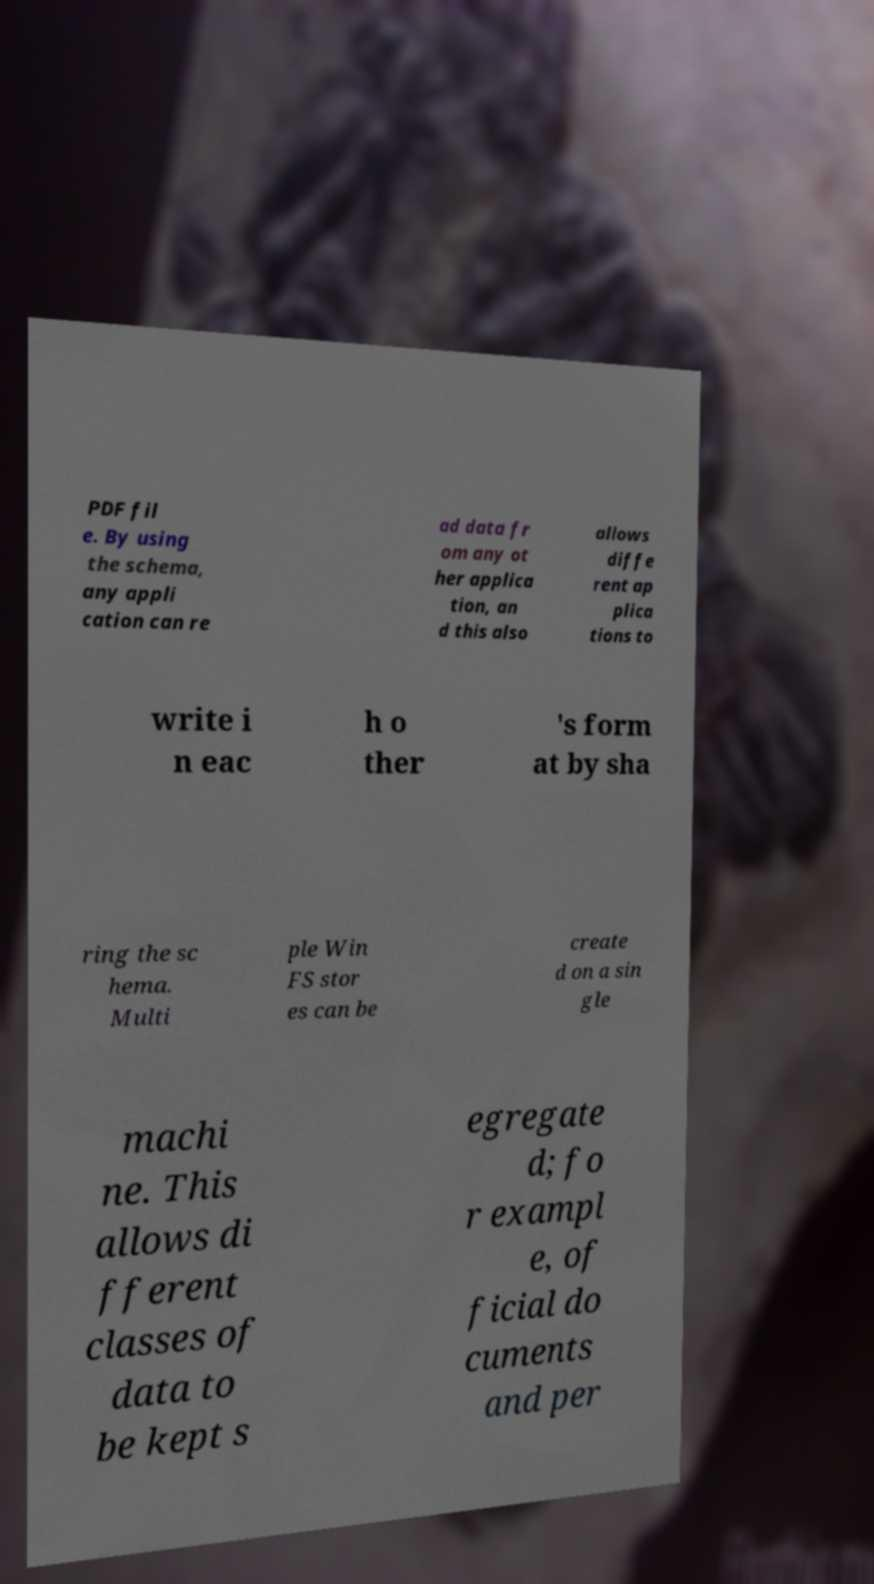Can you accurately transcribe the text from the provided image for me? PDF fil e. By using the schema, any appli cation can re ad data fr om any ot her applica tion, an d this also allows diffe rent ap plica tions to write i n eac h o ther 's form at by sha ring the sc hema. Multi ple Win FS stor es can be create d on a sin gle machi ne. This allows di fferent classes of data to be kept s egregate d; fo r exampl e, of ficial do cuments and per 